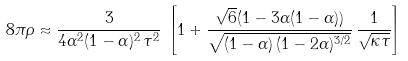<formula> <loc_0><loc_0><loc_500><loc_500>8 \pi \rho \approx \frac { 3 } { 4 \alpha ^ { 2 } ( 1 - \alpha ) ^ { 2 } \, \tau ^ { 2 } } \, \left [ 1 + \frac { \sqrt { 6 } ( 1 - 3 \alpha ( 1 - \alpha ) ) } { \sqrt { ( 1 - \alpha ) \, ( 1 - 2 \alpha ) ^ { 3 / 2 } } } \, \frac { 1 } { \sqrt { \kappa \tau } } \right ]</formula> 